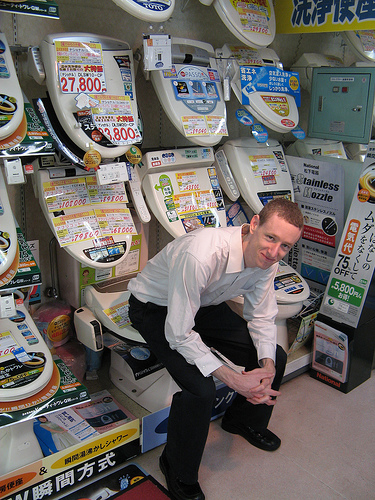Which is older, the lady or the boy? The lady appears to be older than the boy, suggesting a possible mother-son scenario in this amusing store setup. 